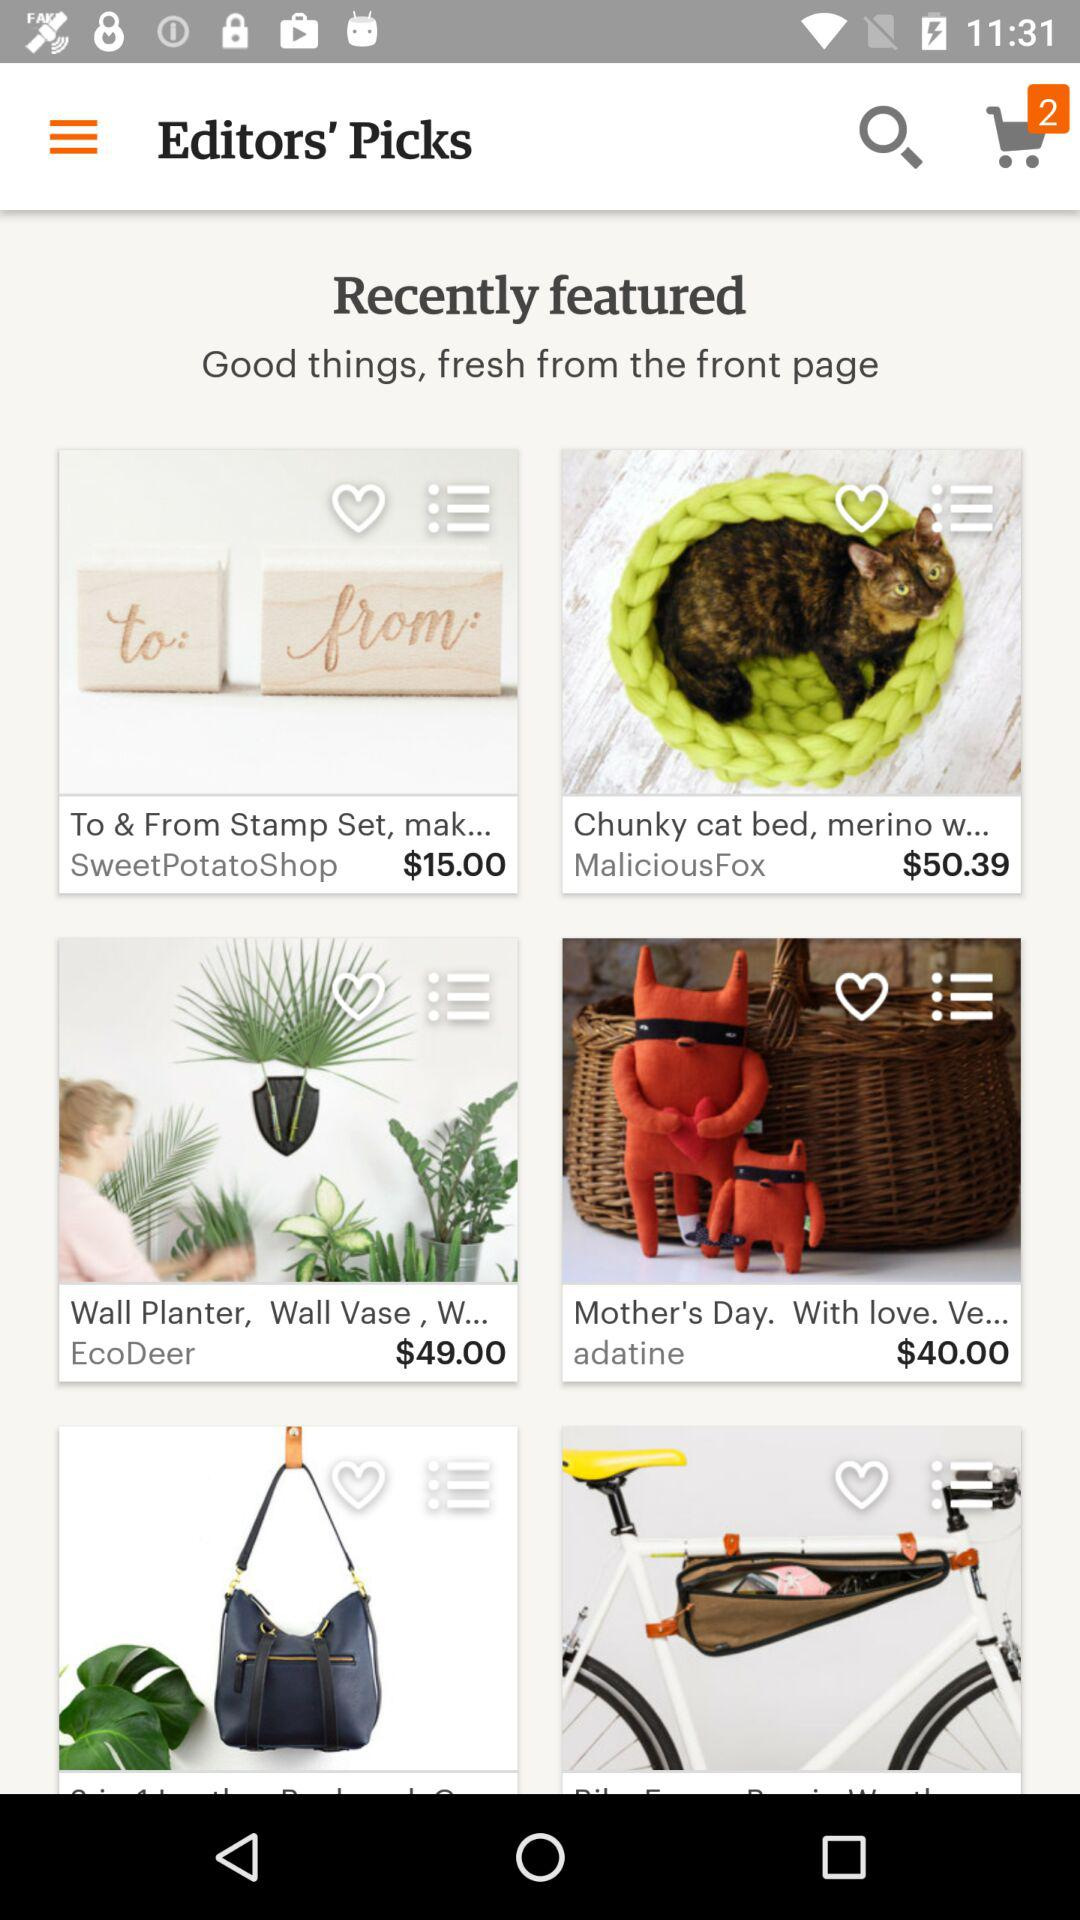What is the price of "To & From Stamp Set, mak..."? The price of "To & From Stamp Set, mak..." is $15.00. 